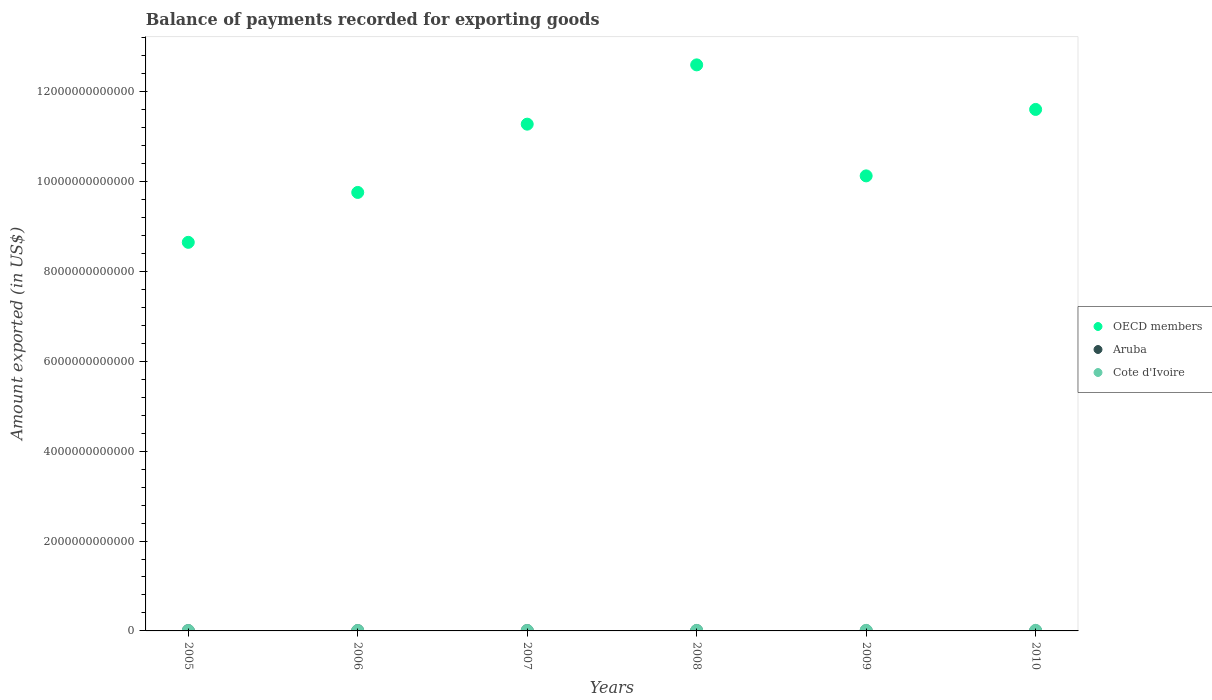How many different coloured dotlines are there?
Ensure brevity in your answer.  3. What is the amount exported in Cote d'Ivoire in 2007?
Your answer should be compact. 9.59e+09. Across all years, what is the maximum amount exported in Cote d'Ivoire?
Give a very brief answer. 1.26e+1. Across all years, what is the minimum amount exported in Cote d'Ivoire?
Your answer should be compact. 8.52e+09. What is the total amount exported in Cote d'Ivoire in the graph?
Offer a terse response. 6.38e+1. What is the difference between the amount exported in OECD members in 2009 and that in 2010?
Your answer should be very brief. -1.48e+12. What is the difference between the amount exported in OECD members in 2005 and the amount exported in Aruba in 2010?
Provide a short and direct response. 8.64e+12. What is the average amount exported in Aruba per year?
Offer a very short reply. 5.13e+09. In the year 2008, what is the difference between the amount exported in Aruba and amount exported in Cote d'Ivoire?
Give a very brief answer. -4.35e+09. In how many years, is the amount exported in OECD members greater than 1600000000000 US$?
Offer a terse response. 6. What is the ratio of the amount exported in OECD members in 2008 to that in 2009?
Your answer should be very brief. 1.24. Is the difference between the amount exported in Aruba in 2009 and 2010 greater than the difference between the amount exported in Cote d'Ivoire in 2009 and 2010?
Offer a very short reply. Yes. What is the difference between the highest and the second highest amount exported in OECD members?
Make the answer very short. 9.91e+11. What is the difference between the highest and the lowest amount exported in OECD members?
Keep it short and to the point. 3.95e+12. Is the amount exported in Cote d'Ivoire strictly less than the amount exported in Aruba over the years?
Keep it short and to the point. No. How many dotlines are there?
Your answer should be very brief. 3. How many years are there in the graph?
Your answer should be very brief. 6. What is the difference between two consecutive major ticks on the Y-axis?
Your answer should be compact. 2.00e+12. Are the values on the major ticks of Y-axis written in scientific E-notation?
Your answer should be compact. No. Does the graph contain any zero values?
Ensure brevity in your answer.  No. How many legend labels are there?
Your response must be concise. 3. What is the title of the graph?
Your answer should be compact. Balance of payments recorded for exporting goods. Does "Argentina" appear as one of the legend labels in the graph?
Your answer should be very brief. No. What is the label or title of the X-axis?
Keep it short and to the point. Years. What is the label or title of the Y-axis?
Your response must be concise. Amount exported (in US$). What is the Amount exported (in US$) in OECD members in 2005?
Provide a short and direct response. 8.65e+12. What is the Amount exported (in US$) of Aruba in 2005?
Offer a very short reply. 5.72e+09. What is the Amount exported (in US$) of Cote d'Ivoire in 2005?
Your response must be concise. 8.52e+09. What is the Amount exported (in US$) of OECD members in 2006?
Ensure brevity in your answer.  9.76e+12. What is the Amount exported (in US$) of Aruba in 2006?
Ensure brevity in your answer.  6.03e+09. What is the Amount exported (in US$) of Cote d'Ivoire in 2006?
Your response must be concise. 9.32e+09. What is the Amount exported (in US$) of OECD members in 2007?
Keep it short and to the point. 1.13e+13. What is the Amount exported (in US$) in Aruba in 2007?
Give a very brief answer. 6.68e+09. What is the Amount exported (in US$) in Cote d'Ivoire in 2007?
Your response must be concise. 9.59e+09. What is the Amount exported (in US$) of OECD members in 2008?
Your response must be concise. 1.26e+13. What is the Amount exported (in US$) in Aruba in 2008?
Your answer should be very brief. 7.06e+09. What is the Amount exported (in US$) of Cote d'Ivoire in 2008?
Ensure brevity in your answer.  1.14e+1. What is the Amount exported (in US$) of OECD members in 2009?
Give a very brief answer. 1.01e+13. What is the Amount exported (in US$) of Aruba in 2009?
Your answer should be very brief. 3.49e+09. What is the Amount exported (in US$) of Cote d'Ivoire in 2009?
Offer a very short reply. 1.23e+1. What is the Amount exported (in US$) of OECD members in 2010?
Your response must be concise. 1.16e+13. What is the Amount exported (in US$) in Aruba in 2010?
Offer a terse response. 1.82e+09. What is the Amount exported (in US$) in Cote d'Ivoire in 2010?
Your response must be concise. 1.26e+1. Across all years, what is the maximum Amount exported (in US$) of OECD members?
Keep it short and to the point. 1.26e+13. Across all years, what is the maximum Amount exported (in US$) in Aruba?
Keep it short and to the point. 7.06e+09. Across all years, what is the maximum Amount exported (in US$) of Cote d'Ivoire?
Make the answer very short. 1.26e+1. Across all years, what is the minimum Amount exported (in US$) in OECD members?
Your response must be concise. 8.65e+12. Across all years, what is the minimum Amount exported (in US$) of Aruba?
Your response must be concise. 1.82e+09. Across all years, what is the minimum Amount exported (in US$) in Cote d'Ivoire?
Give a very brief answer. 8.52e+09. What is the total Amount exported (in US$) of OECD members in the graph?
Offer a terse response. 6.40e+13. What is the total Amount exported (in US$) in Aruba in the graph?
Offer a very short reply. 3.08e+1. What is the total Amount exported (in US$) of Cote d'Ivoire in the graph?
Your answer should be very brief. 6.38e+1. What is the difference between the Amount exported (in US$) of OECD members in 2005 and that in 2006?
Give a very brief answer. -1.11e+12. What is the difference between the Amount exported (in US$) in Aruba in 2005 and that in 2006?
Your answer should be compact. -3.02e+08. What is the difference between the Amount exported (in US$) in Cote d'Ivoire in 2005 and that in 2006?
Provide a succinct answer. -7.92e+08. What is the difference between the Amount exported (in US$) of OECD members in 2005 and that in 2007?
Your response must be concise. -2.63e+12. What is the difference between the Amount exported (in US$) of Aruba in 2005 and that in 2007?
Provide a short and direct response. -9.54e+08. What is the difference between the Amount exported (in US$) of Cote d'Ivoire in 2005 and that in 2007?
Provide a short and direct response. -1.07e+09. What is the difference between the Amount exported (in US$) of OECD members in 2005 and that in 2008?
Your answer should be very brief. -3.95e+12. What is the difference between the Amount exported (in US$) in Aruba in 2005 and that in 2008?
Offer a terse response. -1.34e+09. What is the difference between the Amount exported (in US$) of Cote d'Ivoire in 2005 and that in 2008?
Offer a very short reply. -2.88e+09. What is the difference between the Amount exported (in US$) of OECD members in 2005 and that in 2009?
Ensure brevity in your answer.  -1.48e+12. What is the difference between the Amount exported (in US$) in Aruba in 2005 and that in 2009?
Ensure brevity in your answer.  2.23e+09. What is the difference between the Amount exported (in US$) in Cote d'Ivoire in 2005 and that in 2009?
Your response must be concise. -3.82e+09. What is the difference between the Amount exported (in US$) of OECD members in 2005 and that in 2010?
Your answer should be very brief. -2.96e+12. What is the difference between the Amount exported (in US$) in Aruba in 2005 and that in 2010?
Give a very brief answer. 3.90e+09. What is the difference between the Amount exported (in US$) of Cote d'Ivoire in 2005 and that in 2010?
Provide a short and direct response. -4.07e+09. What is the difference between the Amount exported (in US$) in OECD members in 2006 and that in 2007?
Your answer should be compact. -1.52e+12. What is the difference between the Amount exported (in US$) in Aruba in 2006 and that in 2007?
Your answer should be very brief. -6.52e+08. What is the difference between the Amount exported (in US$) of Cote d'Ivoire in 2006 and that in 2007?
Provide a succinct answer. -2.79e+08. What is the difference between the Amount exported (in US$) in OECD members in 2006 and that in 2008?
Provide a succinct answer. -2.84e+12. What is the difference between the Amount exported (in US$) in Aruba in 2006 and that in 2008?
Provide a succinct answer. -1.03e+09. What is the difference between the Amount exported (in US$) in Cote d'Ivoire in 2006 and that in 2008?
Keep it short and to the point. -2.09e+09. What is the difference between the Amount exported (in US$) of OECD members in 2006 and that in 2009?
Offer a terse response. -3.68e+11. What is the difference between the Amount exported (in US$) of Aruba in 2006 and that in 2009?
Ensure brevity in your answer.  2.54e+09. What is the difference between the Amount exported (in US$) of Cote d'Ivoire in 2006 and that in 2009?
Your response must be concise. -3.02e+09. What is the difference between the Amount exported (in US$) in OECD members in 2006 and that in 2010?
Provide a succinct answer. -1.85e+12. What is the difference between the Amount exported (in US$) in Aruba in 2006 and that in 2010?
Ensure brevity in your answer.  4.20e+09. What is the difference between the Amount exported (in US$) of Cote d'Ivoire in 2006 and that in 2010?
Offer a terse response. -3.28e+09. What is the difference between the Amount exported (in US$) of OECD members in 2007 and that in 2008?
Ensure brevity in your answer.  -1.32e+12. What is the difference between the Amount exported (in US$) of Aruba in 2007 and that in 2008?
Keep it short and to the point. -3.82e+08. What is the difference between the Amount exported (in US$) of Cote d'Ivoire in 2007 and that in 2008?
Make the answer very short. -1.81e+09. What is the difference between the Amount exported (in US$) of OECD members in 2007 and that in 2009?
Provide a short and direct response. 1.15e+12. What is the difference between the Amount exported (in US$) in Aruba in 2007 and that in 2009?
Offer a very short reply. 3.19e+09. What is the difference between the Amount exported (in US$) in Cote d'Ivoire in 2007 and that in 2009?
Ensure brevity in your answer.  -2.75e+09. What is the difference between the Amount exported (in US$) of OECD members in 2007 and that in 2010?
Offer a terse response. -3.28e+11. What is the difference between the Amount exported (in US$) of Aruba in 2007 and that in 2010?
Offer a very short reply. 4.85e+09. What is the difference between the Amount exported (in US$) in Cote d'Ivoire in 2007 and that in 2010?
Ensure brevity in your answer.  -3.00e+09. What is the difference between the Amount exported (in US$) of OECD members in 2008 and that in 2009?
Ensure brevity in your answer.  2.47e+12. What is the difference between the Amount exported (in US$) in Aruba in 2008 and that in 2009?
Offer a very short reply. 3.57e+09. What is the difference between the Amount exported (in US$) of Cote d'Ivoire in 2008 and that in 2009?
Your answer should be very brief. -9.33e+08. What is the difference between the Amount exported (in US$) of OECD members in 2008 and that in 2010?
Your answer should be compact. 9.91e+11. What is the difference between the Amount exported (in US$) of Aruba in 2008 and that in 2010?
Your answer should be very brief. 5.24e+09. What is the difference between the Amount exported (in US$) in Cote d'Ivoire in 2008 and that in 2010?
Make the answer very short. -1.19e+09. What is the difference between the Amount exported (in US$) in OECD members in 2009 and that in 2010?
Make the answer very short. -1.48e+12. What is the difference between the Amount exported (in US$) of Aruba in 2009 and that in 2010?
Provide a short and direct response. 1.67e+09. What is the difference between the Amount exported (in US$) in Cote d'Ivoire in 2009 and that in 2010?
Provide a succinct answer. -2.54e+08. What is the difference between the Amount exported (in US$) in OECD members in 2005 and the Amount exported (in US$) in Aruba in 2006?
Offer a very short reply. 8.64e+12. What is the difference between the Amount exported (in US$) of OECD members in 2005 and the Amount exported (in US$) of Cote d'Ivoire in 2006?
Provide a succinct answer. 8.64e+12. What is the difference between the Amount exported (in US$) in Aruba in 2005 and the Amount exported (in US$) in Cote d'Ivoire in 2006?
Provide a succinct answer. -3.59e+09. What is the difference between the Amount exported (in US$) in OECD members in 2005 and the Amount exported (in US$) in Aruba in 2007?
Your answer should be very brief. 8.64e+12. What is the difference between the Amount exported (in US$) of OECD members in 2005 and the Amount exported (in US$) of Cote d'Ivoire in 2007?
Ensure brevity in your answer.  8.64e+12. What is the difference between the Amount exported (in US$) of Aruba in 2005 and the Amount exported (in US$) of Cote d'Ivoire in 2007?
Your answer should be compact. -3.87e+09. What is the difference between the Amount exported (in US$) in OECD members in 2005 and the Amount exported (in US$) in Aruba in 2008?
Provide a succinct answer. 8.64e+12. What is the difference between the Amount exported (in US$) of OECD members in 2005 and the Amount exported (in US$) of Cote d'Ivoire in 2008?
Offer a terse response. 8.64e+12. What is the difference between the Amount exported (in US$) in Aruba in 2005 and the Amount exported (in US$) in Cote d'Ivoire in 2008?
Keep it short and to the point. -5.68e+09. What is the difference between the Amount exported (in US$) of OECD members in 2005 and the Amount exported (in US$) of Aruba in 2009?
Your answer should be compact. 8.64e+12. What is the difference between the Amount exported (in US$) of OECD members in 2005 and the Amount exported (in US$) of Cote d'Ivoire in 2009?
Give a very brief answer. 8.63e+12. What is the difference between the Amount exported (in US$) of Aruba in 2005 and the Amount exported (in US$) of Cote d'Ivoire in 2009?
Your response must be concise. -6.62e+09. What is the difference between the Amount exported (in US$) of OECD members in 2005 and the Amount exported (in US$) of Aruba in 2010?
Offer a very short reply. 8.64e+12. What is the difference between the Amount exported (in US$) in OECD members in 2005 and the Amount exported (in US$) in Cote d'Ivoire in 2010?
Make the answer very short. 8.63e+12. What is the difference between the Amount exported (in US$) in Aruba in 2005 and the Amount exported (in US$) in Cote d'Ivoire in 2010?
Give a very brief answer. -6.87e+09. What is the difference between the Amount exported (in US$) in OECD members in 2006 and the Amount exported (in US$) in Aruba in 2007?
Offer a very short reply. 9.75e+12. What is the difference between the Amount exported (in US$) of OECD members in 2006 and the Amount exported (in US$) of Cote d'Ivoire in 2007?
Keep it short and to the point. 9.75e+12. What is the difference between the Amount exported (in US$) in Aruba in 2006 and the Amount exported (in US$) in Cote d'Ivoire in 2007?
Make the answer very short. -3.57e+09. What is the difference between the Amount exported (in US$) in OECD members in 2006 and the Amount exported (in US$) in Aruba in 2008?
Provide a succinct answer. 9.75e+12. What is the difference between the Amount exported (in US$) in OECD members in 2006 and the Amount exported (in US$) in Cote d'Ivoire in 2008?
Make the answer very short. 9.75e+12. What is the difference between the Amount exported (in US$) in Aruba in 2006 and the Amount exported (in US$) in Cote d'Ivoire in 2008?
Offer a very short reply. -5.38e+09. What is the difference between the Amount exported (in US$) in OECD members in 2006 and the Amount exported (in US$) in Aruba in 2009?
Ensure brevity in your answer.  9.75e+12. What is the difference between the Amount exported (in US$) in OECD members in 2006 and the Amount exported (in US$) in Cote d'Ivoire in 2009?
Your answer should be very brief. 9.74e+12. What is the difference between the Amount exported (in US$) in Aruba in 2006 and the Amount exported (in US$) in Cote d'Ivoire in 2009?
Your answer should be compact. -6.31e+09. What is the difference between the Amount exported (in US$) of OECD members in 2006 and the Amount exported (in US$) of Aruba in 2010?
Offer a very short reply. 9.76e+12. What is the difference between the Amount exported (in US$) in OECD members in 2006 and the Amount exported (in US$) in Cote d'Ivoire in 2010?
Provide a succinct answer. 9.74e+12. What is the difference between the Amount exported (in US$) in Aruba in 2006 and the Amount exported (in US$) in Cote d'Ivoire in 2010?
Provide a short and direct response. -6.57e+09. What is the difference between the Amount exported (in US$) of OECD members in 2007 and the Amount exported (in US$) of Aruba in 2008?
Keep it short and to the point. 1.13e+13. What is the difference between the Amount exported (in US$) in OECD members in 2007 and the Amount exported (in US$) in Cote d'Ivoire in 2008?
Your answer should be very brief. 1.13e+13. What is the difference between the Amount exported (in US$) in Aruba in 2007 and the Amount exported (in US$) in Cote d'Ivoire in 2008?
Offer a terse response. -4.73e+09. What is the difference between the Amount exported (in US$) in OECD members in 2007 and the Amount exported (in US$) in Aruba in 2009?
Offer a very short reply. 1.13e+13. What is the difference between the Amount exported (in US$) in OECD members in 2007 and the Amount exported (in US$) in Cote d'Ivoire in 2009?
Give a very brief answer. 1.13e+13. What is the difference between the Amount exported (in US$) of Aruba in 2007 and the Amount exported (in US$) of Cote d'Ivoire in 2009?
Keep it short and to the point. -5.66e+09. What is the difference between the Amount exported (in US$) in OECD members in 2007 and the Amount exported (in US$) in Aruba in 2010?
Keep it short and to the point. 1.13e+13. What is the difference between the Amount exported (in US$) in OECD members in 2007 and the Amount exported (in US$) in Cote d'Ivoire in 2010?
Keep it short and to the point. 1.13e+13. What is the difference between the Amount exported (in US$) of Aruba in 2007 and the Amount exported (in US$) of Cote d'Ivoire in 2010?
Provide a short and direct response. -5.92e+09. What is the difference between the Amount exported (in US$) in OECD members in 2008 and the Amount exported (in US$) in Aruba in 2009?
Make the answer very short. 1.26e+13. What is the difference between the Amount exported (in US$) of OECD members in 2008 and the Amount exported (in US$) of Cote d'Ivoire in 2009?
Your answer should be very brief. 1.26e+13. What is the difference between the Amount exported (in US$) of Aruba in 2008 and the Amount exported (in US$) of Cote d'Ivoire in 2009?
Make the answer very short. -5.28e+09. What is the difference between the Amount exported (in US$) in OECD members in 2008 and the Amount exported (in US$) in Aruba in 2010?
Your answer should be very brief. 1.26e+13. What is the difference between the Amount exported (in US$) in OECD members in 2008 and the Amount exported (in US$) in Cote d'Ivoire in 2010?
Offer a terse response. 1.26e+13. What is the difference between the Amount exported (in US$) of Aruba in 2008 and the Amount exported (in US$) of Cote d'Ivoire in 2010?
Give a very brief answer. -5.53e+09. What is the difference between the Amount exported (in US$) in OECD members in 2009 and the Amount exported (in US$) in Aruba in 2010?
Your answer should be very brief. 1.01e+13. What is the difference between the Amount exported (in US$) in OECD members in 2009 and the Amount exported (in US$) in Cote d'Ivoire in 2010?
Give a very brief answer. 1.01e+13. What is the difference between the Amount exported (in US$) in Aruba in 2009 and the Amount exported (in US$) in Cote d'Ivoire in 2010?
Offer a very short reply. -9.10e+09. What is the average Amount exported (in US$) of OECD members per year?
Offer a terse response. 1.07e+13. What is the average Amount exported (in US$) in Aruba per year?
Ensure brevity in your answer.  5.13e+09. What is the average Amount exported (in US$) in Cote d'Ivoire per year?
Offer a terse response. 1.06e+1. In the year 2005, what is the difference between the Amount exported (in US$) in OECD members and Amount exported (in US$) in Aruba?
Your response must be concise. 8.64e+12. In the year 2005, what is the difference between the Amount exported (in US$) of OECD members and Amount exported (in US$) of Cote d'Ivoire?
Your answer should be very brief. 8.64e+12. In the year 2005, what is the difference between the Amount exported (in US$) of Aruba and Amount exported (in US$) of Cote d'Ivoire?
Your answer should be very brief. -2.80e+09. In the year 2006, what is the difference between the Amount exported (in US$) of OECD members and Amount exported (in US$) of Aruba?
Give a very brief answer. 9.75e+12. In the year 2006, what is the difference between the Amount exported (in US$) of OECD members and Amount exported (in US$) of Cote d'Ivoire?
Your response must be concise. 9.75e+12. In the year 2006, what is the difference between the Amount exported (in US$) of Aruba and Amount exported (in US$) of Cote d'Ivoire?
Provide a short and direct response. -3.29e+09. In the year 2007, what is the difference between the Amount exported (in US$) of OECD members and Amount exported (in US$) of Aruba?
Your answer should be very brief. 1.13e+13. In the year 2007, what is the difference between the Amount exported (in US$) in OECD members and Amount exported (in US$) in Cote d'Ivoire?
Provide a short and direct response. 1.13e+13. In the year 2007, what is the difference between the Amount exported (in US$) of Aruba and Amount exported (in US$) of Cote d'Ivoire?
Give a very brief answer. -2.92e+09. In the year 2008, what is the difference between the Amount exported (in US$) of OECD members and Amount exported (in US$) of Aruba?
Offer a terse response. 1.26e+13. In the year 2008, what is the difference between the Amount exported (in US$) in OECD members and Amount exported (in US$) in Cote d'Ivoire?
Provide a short and direct response. 1.26e+13. In the year 2008, what is the difference between the Amount exported (in US$) of Aruba and Amount exported (in US$) of Cote d'Ivoire?
Give a very brief answer. -4.35e+09. In the year 2009, what is the difference between the Amount exported (in US$) of OECD members and Amount exported (in US$) of Aruba?
Ensure brevity in your answer.  1.01e+13. In the year 2009, what is the difference between the Amount exported (in US$) of OECD members and Amount exported (in US$) of Cote d'Ivoire?
Your answer should be compact. 1.01e+13. In the year 2009, what is the difference between the Amount exported (in US$) in Aruba and Amount exported (in US$) in Cote d'Ivoire?
Provide a succinct answer. -8.85e+09. In the year 2010, what is the difference between the Amount exported (in US$) of OECD members and Amount exported (in US$) of Aruba?
Ensure brevity in your answer.  1.16e+13. In the year 2010, what is the difference between the Amount exported (in US$) in OECD members and Amount exported (in US$) in Cote d'Ivoire?
Keep it short and to the point. 1.16e+13. In the year 2010, what is the difference between the Amount exported (in US$) in Aruba and Amount exported (in US$) in Cote d'Ivoire?
Your answer should be very brief. -1.08e+1. What is the ratio of the Amount exported (in US$) in OECD members in 2005 to that in 2006?
Provide a succinct answer. 0.89. What is the ratio of the Amount exported (in US$) of Aruba in 2005 to that in 2006?
Your answer should be compact. 0.95. What is the ratio of the Amount exported (in US$) of Cote d'Ivoire in 2005 to that in 2006?
Ensure brevity in your answer.  0.92. What is the ratio of the Amount exported (in US$) in OECD members in 2005 to that in 2007?
Your answer should be compact. 0.77. What is the ratio of the Amount exported (in US$) of Aruba in 2005 to that in 2007?
Keep it short and to the point. 0.86. What is the ratio of the Amount exported (in US$) in Cote d'Ivoire in 2005 to that in 2007?
Provide a short and direct response. 0.89. What is the ratio of the Amount exported (in US$) of OECD members in 2005 to that in 2008?
Provide a short and direct response. 0.69. What is the ratio of the Amount exported (in US$) in Aruba in 2005 to that in 2008?
Offer a terse response. 0.81. What is the ratio of the Amount exported (in US$) of Cote d'Ivoire in 2005 to that in 2008?
Provide a short and direct response. 0.75. What is the ratio of the Amount exported (in US$) in OECD members in 2005 to that in 2009?
Keep it short and to the point. 0.85. What is the ratio of the Amount exported (in US$) of Aruba in 2005 to that in 2009?
Give a very brief answer. 1.64. What is the ratio of the Amount exported (in US$) in Cote d'Ivoire in 2005 to that in 2009?
Provide a short and direct response. 0.69. What is the ratio of the Amount exported (in US$) of OECD members in 2005 to that in 2010?
Offer a very short reply. 0.75. What is the ratio of the Amount exported (in US$) of Aruba in 2005 to that in 2010?
Give a very brief answer. 3.14. What is the ratio of the Amount exported (in US$) of Cote d'Ivoire in 2005 to that in 2010?
Make the answer very short. 0.68. What is the ratio of the Amount exported (in US$) of OECD members in 2006 to that in 2007?
Keep it short and to the point. 0.87. What is the ratio of the Amount exported (in US$) in Aruba in 2006 to that in 2007?
Provide a succinct answer. 0.9. What is the ratio of the Amount exported (in US$) in Cote d'Ivoire in 2006 to that in 2007?
Keep it short and to the point. 0.97. What is the ratio of the Amount exported (in US$) of OECD members in 2006 to that in 2008?
Make the answer very short. 0.77. What is the ratio of the Amount exported (in US$) of Aruba in 2006 to that in 2008?
Your answer should be very brief. 0.85. What is the ratio of the Amount exported (in US$) of Cote d'Ivoire in 2006 to that in 2008?
Ensure brevity in your answer.  0.82. What is the ratio of the Amount exported (in US$) in OECD members in 2006 to that in 2009?
Your answer should be very brief. 0.96. What is the ratio of the Amount exported (in US$) of Aruba in 2006 to that in 2009?
Keep it short and to the point. 1.73. What is the ratio of the Amount exported (in US$) in Cote d'Ivoire in 2006 to that in 2009?
Ensure brevity in your answer.  0.75. What is the ratio of the Amount exported (in US$) in OECD members in 2006 to that in 2010?
Offer a terse response. 0.84. What is the ratio of the Amount exported (in US$) of Aruba in 2006 to that in 2010?
Your answer should be very brief. 3.3. What is the ratio of the Amount exported (in US$) in Cote d'Ivoire in 2006 to that in 2010?
Give a very brief answer. 0.74. What is the ratio of the Amount exported (in US$) in OECD members in 2007 to that in 2008?
Provide a short and direct response. 0.9. What is the ratio of the Amount exported (in US$) of Aruba in 2007 to that in 2008?
Offer a very short reply. 0.95. What is the ratio of the Amount exported (in US$) in Cote d'Ivoire in 2007 to that in 2008?
Your answer should be very brief. 0.84. What is the ratio of the Amount exported (in US$) of OECD members in 2007 to that in 2009?
Ensure brevity in your answer.  1.11. What is the ratio of the Amount exported (in US$) in Aruba in 2007 to that in 2009?
Offer a terse response. 1.91. What is the ratio of the Amount exported (in US$) in Cote d'Ivoire in 2007 to that in 2009?
Keep it short and to the point. 0.78. What is the ratio of the Amount exported (in US$) of OECD members in 2007 to that in 2010?
Offer a very short reply. 0.97. What is the ratio of the Amount exported (in US$) of Aruba in 2007 to that in 2010?
Your answer should be very brief. 3.66. What is the ratio of the Amount exported (in US$) of Cote d'Ivoire in 2007 to that in 2010?
Your response must be concise. 0.76. What is the ratio of the Amount exported (in US$) in OECD members in 2008 to that in 2009?
Your answer should be very brief. 1.24. What is the ratio of the Amount exported (in US$) in Aruba in 2008 to that in 2009?
Keep it short and to the point. 2.02. What is the ratio of the Amount exported (in US$) in Cote d'Ivoire in 2008 to that in 2009?
Your answer should be very brief. 0.92. What is the ratio of the Amount exported (in US$) of OECD members in 2008 to that in 2010?
Provide a short and direct response. 1.09. What is the ratio of the Amount exported (in US$) in Aruba in 2008 to that in 2010?
Make the answer very short. 3.87. What is the ratio of the Amount exported (in US$) in Cote d'Ivoire in 2008 to that in 2010?
Provide a succinct answer. 0.91. What is the ratio of the Amount exported (in US$) in OECD members in 2009 to that in 2010?
Your response must be concise. 0.87. What is the ratio of the Amount exported (in US$) of Aruba in 2009 to that in 2010?
Give a very brief answer. 1.91. What is the ratio of the Amount exported (in US$) in Cote d'Ivoire in 2009 to that in 2010?
Keep it short and to the point. 0.98. What is the difference between the highest and the second highest Amount exported (in US$) in OECD members?
Provide a short and direct response. 9.91e+11. What is the difference between the highest and the second highest Amount exported (in US$) in Aruba?
Your answer should be compact. 3.82e+08. What is the difference between the highest and the second highest Amount exported (in US$) in Cote d'Ivoire?
Provide a short and direct response. 2.54e+08. What is the difference between the highest and the lowest Amount exported (in US$) of OECD members?
Keep it short and to the point. 3.95e+12. What is the difference between the highest and the lowest Amount exported (in US$) in Aruba?
Your answer should be very brief. 5.24e+09. What is the difference between the highest and the lowest Amount exported (in US$) of Cote d'Ivoire?
Give a very brief answer. 4.07e+09. 